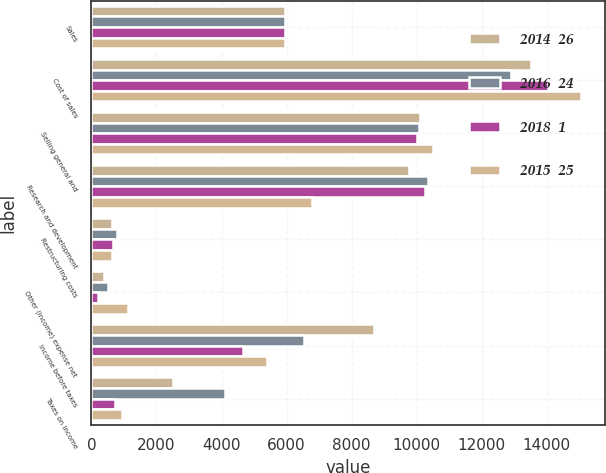Convert chart. <chart><loc_0><loc_0><loc_500><loc_500><stacked_bar_chart><ecel><fcel>Sales<fcel>Cost of sales<fcel>Selling general and<fcel>Research and development<fcel>Restructuring costs<fcel>Other (income) expense net<fcel>Income before taxes<fcel>Taxes on income<nl><fcel>2014  26<fcel>5961<fcel>13509<fcel>10102<fcel>9752<fcel>632<fcel>402<fcel>8701<fcel>2508<nl><fcel>2016  24<fcel>5961<fcel>12912<fcel>10074<fcel>10339<fcel>776<fcel>500<fcel>6521<fcel>4103<nl><fcel>2018  1<fcel>5961<fcel>14030<fcel>10017<fcel>10261<fcel>651<fcel>189<fcel>4659<fcel>718<nl><fcel>2015  25<fcel>5961<fcel>15043<fcel>10508<fcel>6796<fcel>619<fcel>1131<fcel>5401<fcel>942<nl></chart> 